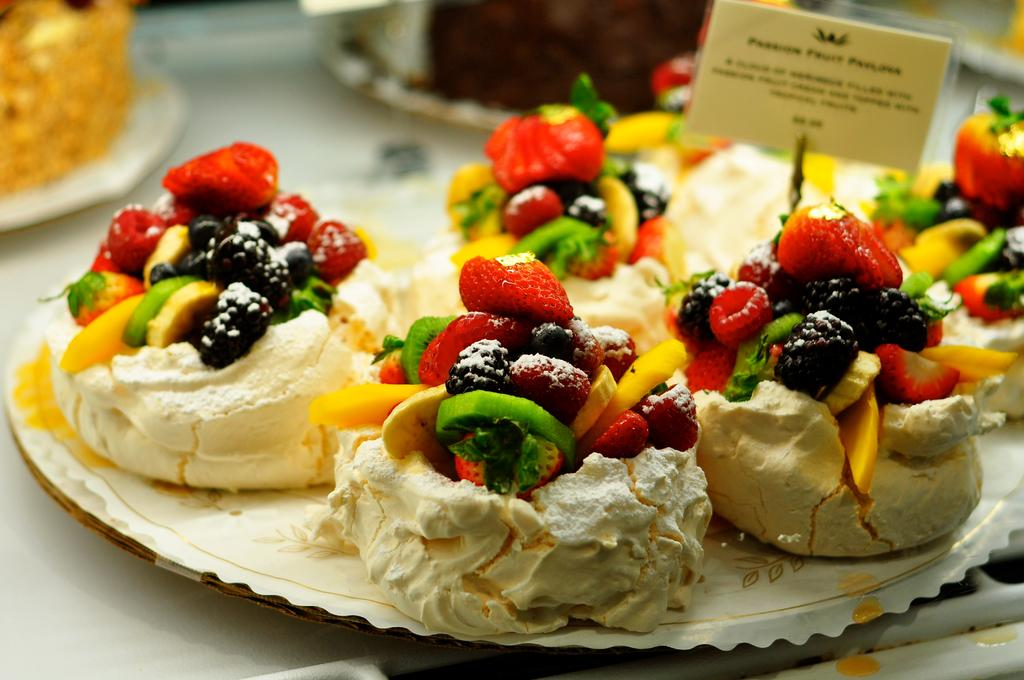What can be seen on the plates in the image? There are food items in plates in the image. What type of written material is present in the image? There is a paper with text in the image. What is the color of the surface at the bottom of the image? The surface at the bottom of the image is white. What type of education can be seen on the moon in the image? There is no moon present in the image, and therefore no education can be seen on it. What type of treatment is being administered to the food items in the image? There is no treatment being administered to the food items in the image; they are simply on plates. 